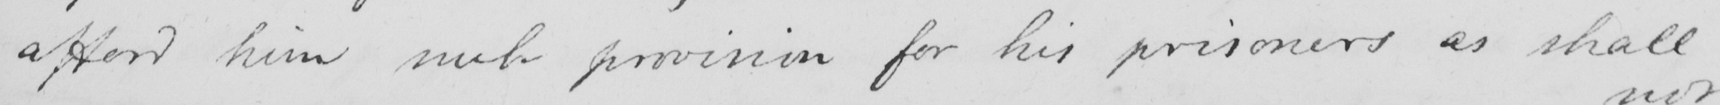Can you read and transcribe this handwriting? afford him such provision for his prisoners as shall 